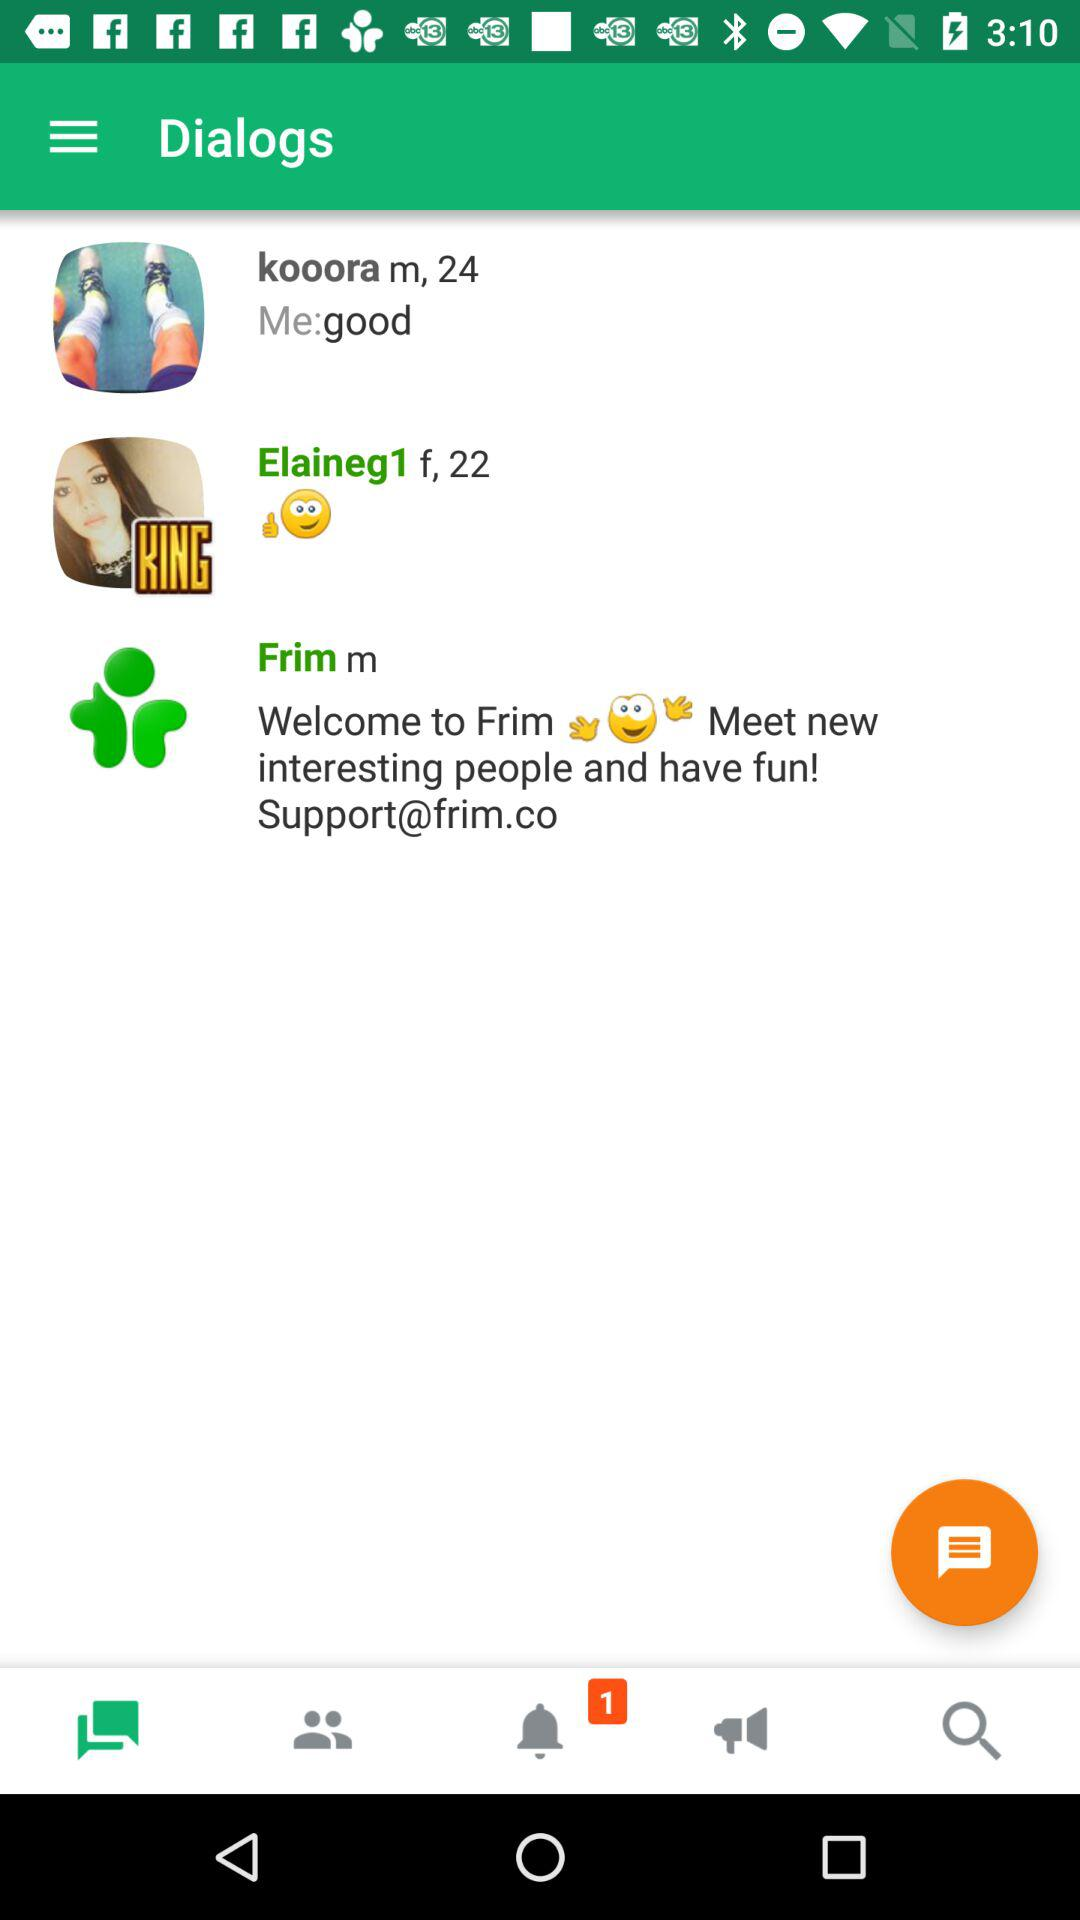Which message is post by kooora?
When the provided information is insufficient, respond with <no answer>. <no answer> 